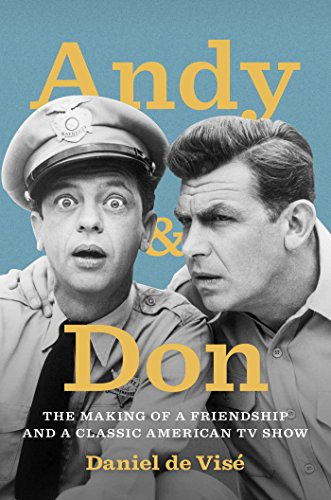Is this book related to Humor & Entertainment? Absolutely, this book is intricately related to Humor & Entertainment, as it celebrates the legacy and the friendship behind one of America's most endearing television series. 